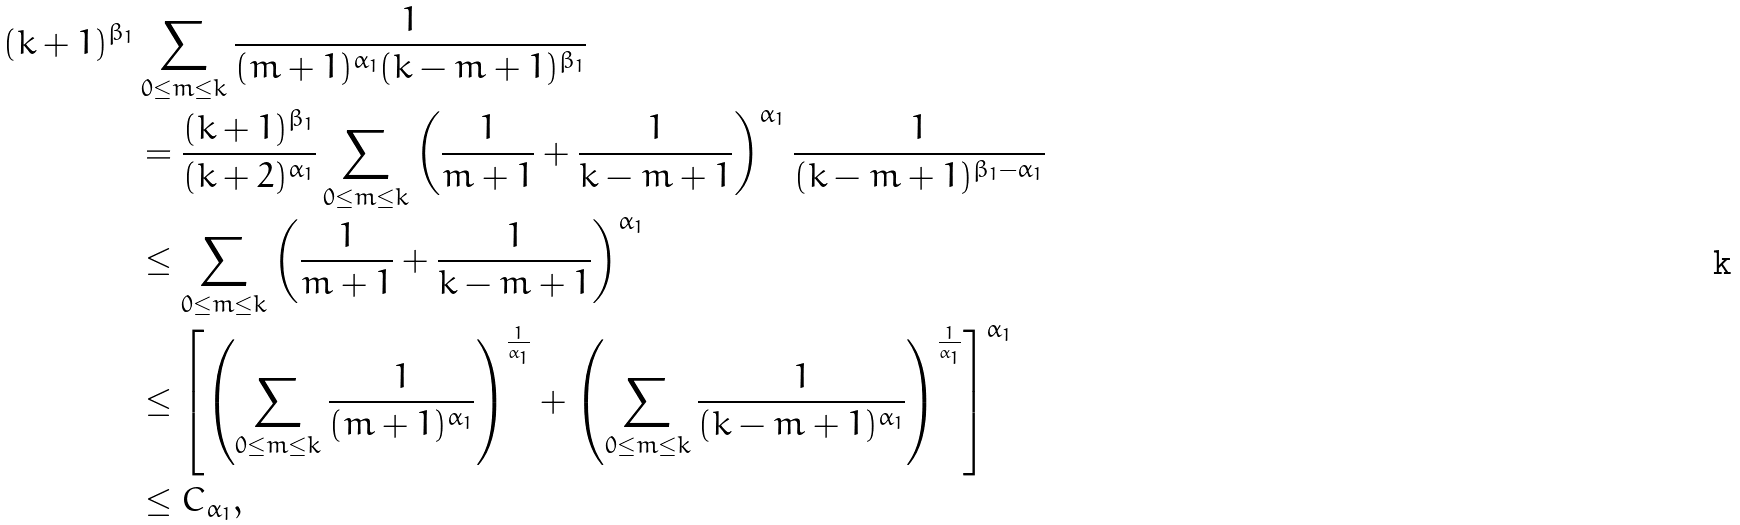Convert formula to latex. <formula><loc_0><loc_0><loc_500><loc_500>( k + 1 ) ^ { \beta _ { 1 } } & \sum _ { 0 \leq m \leq k } \frac { 1 } { ( m + 1 ) ^ { \alpha _ { 1 } } ( k - m + 1 ) ^ { \beta _ { 1 } } } \\ & = \frac { ( k + 1 ) ^ { \beta _ { 1 } } } { ( k + 2 ) ^ { \alpha _ { 1 } } } \sum _ { 0 \leq m \leq k } \left ( \frac { 1 } { m + 1 } + \frac { 1 } { k - m + 1 } \right ) ^ { \alpha _ { 1 } } \frac { 1 } { ( k - m + 1 ) ^ { \beta _ { 1 } - \alpha _ { 1 } } } \\ & \leq \sum _ { 0 \leq m \leq k } \left ( \frac { 1 } { m + 1 } + \frac { 1 } { k - m + 1 } \right ) ^ { \alpha _ { 1 } } \\ & \leq \left [ \left ( \sum _ { 0 \leq m \leq k } \frac { 1 } { ( m + 1 ) ^ { \alpha _ { 1 } } } \right ) ^ { \frac { 1 } { \alpha _ { 1 } } } + \left ( \sum _ { 0 \leq m \leq k } \frac { 1 } { ( k - m + 1 ) ^ { \alpha _ { 1 } } } \right ) ^ { \frac { 1 } { \alpha _ { 1 } } } \right ] ^ { \alpha _ { 1 } } \\ & \leq C _ { \alpha _ { 1 } } ,</formula> 